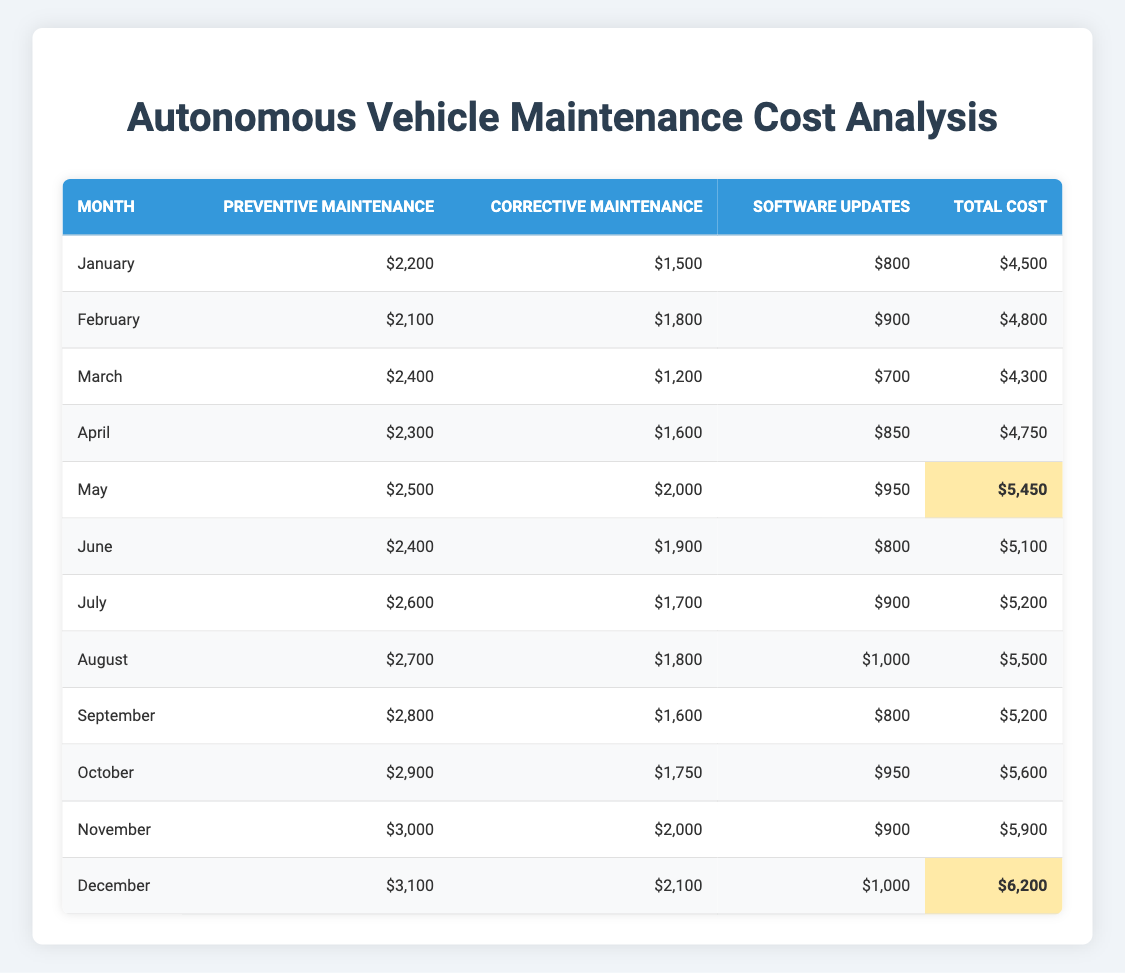What was the total maintenance cost in May? In the table, the total cost for May is listed as $5,450.
Answer: $5,450 Which month had the highest preventive maintenance cost? By looking at the preventive maintenance costs, December shows the highest at $3,100.
Answer: December What is the average corrective maintenance cost across all months? The total corrective maintenance cost from January to December is $1,500 + $1,800 + $1,200 + $1,600 + $2,000 + $1,900 + $1,700 + $1,800 + $1,600 + $1,750 + $2,000 + $2,100 = $21,950. Dividing by 12 months gives an average of $1,829.17.
Answer: $1,829.17 Was the total maintenance cost higher in December than in October? The total costs for December and October are $6,200 and $5,600, respectively. Since $6,200 is greater than $5,600, the statement is true.
Answer: Yes How much did the preventive maintenance costs increase from January to December? The preventive maintenance cost in January was $2,200, and in December it was $3,100. The difference is $3,100 - $2,200 = $900.
Answer: $900 What is the total annual cost of maintenance over the year? Summing total costs from each month gives $4,500 + $4,800 + $4,300 + $4,750 + $5,450 + $5,100 + $5,200 + $5,500 + $5,200 + $5,600 + $5,900 + $6,200 = $64,450.
Answer: $64,450 Which month saw the lowest total cost? The total costs for all months are listed, and March has the lowest total cost at $4,300.
Answer: March If the preventive maintenance cost continued to rise at the same rate as from November to December, what would it be in the following January? The increase from November ($3,000) to December ($3,100) was $100. If this trend continues, the next month's preventive maintenance cost would be $3,100 + $100 = $3,200.
Answer: $3,200 Was the software updates cost in August higher than in September? In August, the software updates cost was $1,000, while in September it was $800. Thus, $1,000 is greater than $800, making the statement true.
Answer: Yes How much more was spent on corrective maintenance in November compared to January? In November, the cost was $2,000, and in January it was $1,500. The difference is $2,000 - $1,500 = $500.
Answer: $500 Which month had a total cost most similar to the average monthly total cost? The total cost for the entire year is $64,450, which averages out to $64,450 / 12 = $5,370.83. The closest total is October at $5,600.
Answer: October 